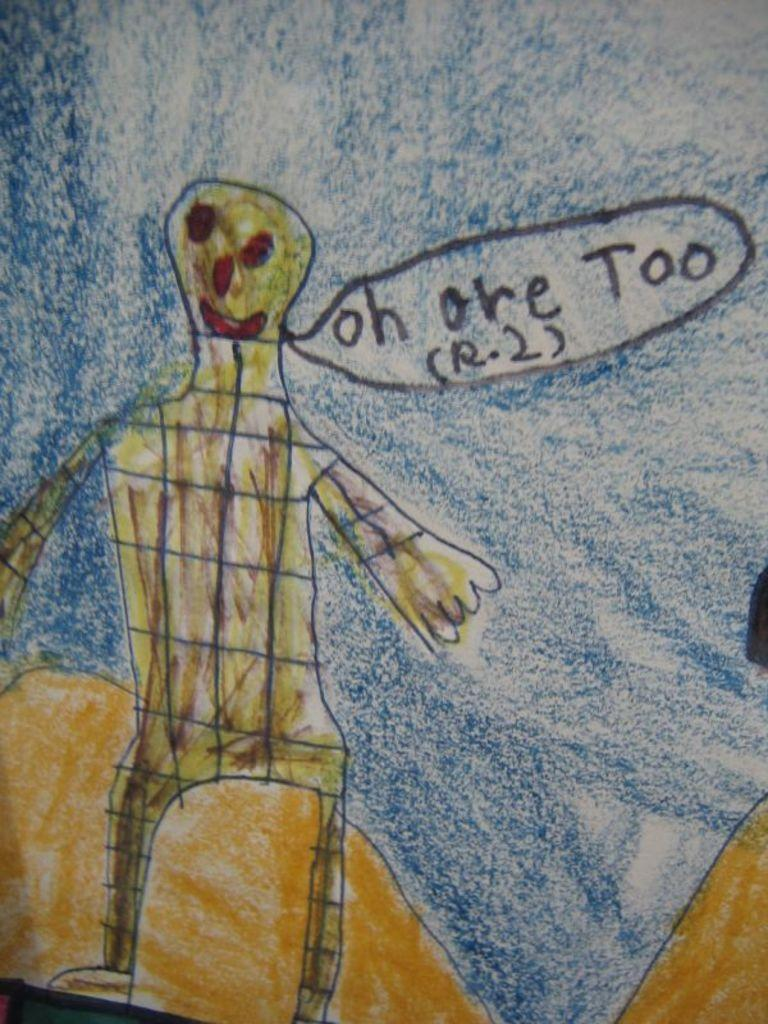What type of artwork is shown in the image? The image appears to be a drawing. What is the main subject of the drawing? The drawing depicts a person. What type of landscape feature is present in the drawing? There is a hill in the drawing. What part of the natural environment is visible in the drawing? The sky is visible in the drawing. How many girls with fangs can be seen in the drawing? There are no girls with fangs present in the drawing; it depicts a person without any fangs. 